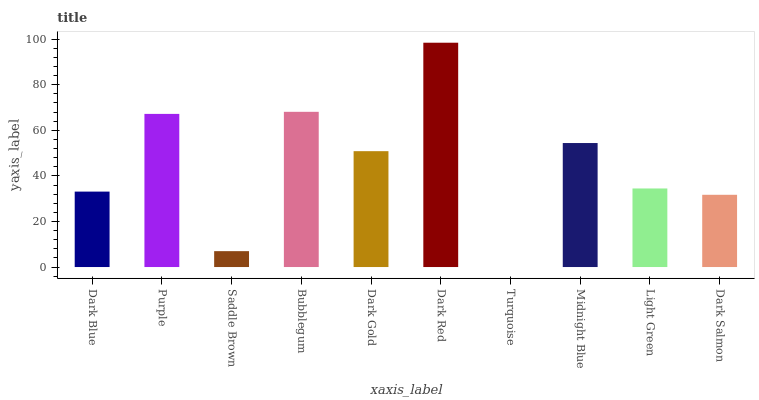Is Purple the minimum?
Answer yes or no. No. Is Purple the maximum?
Answer yes or no. No. Is Purple greater than Dark Blue?
Answer yes or no. Yes. Is Dark Blue less than Purple?
Answer yes or no. Yes. Is Dark Blue greater than Purple?
Answer yes or no. No. Is Purple less than Dark Blue?
Answer yes or no. No. Is Dark Gold the high median?
Answer yes or no. Yes. Is Light Green the low median?
Answer yes or no. Yes. Is Bubblegum the high median?
Answer yes or no. No. Is Saddle Brown the low median?
Answer yes or no. No. 